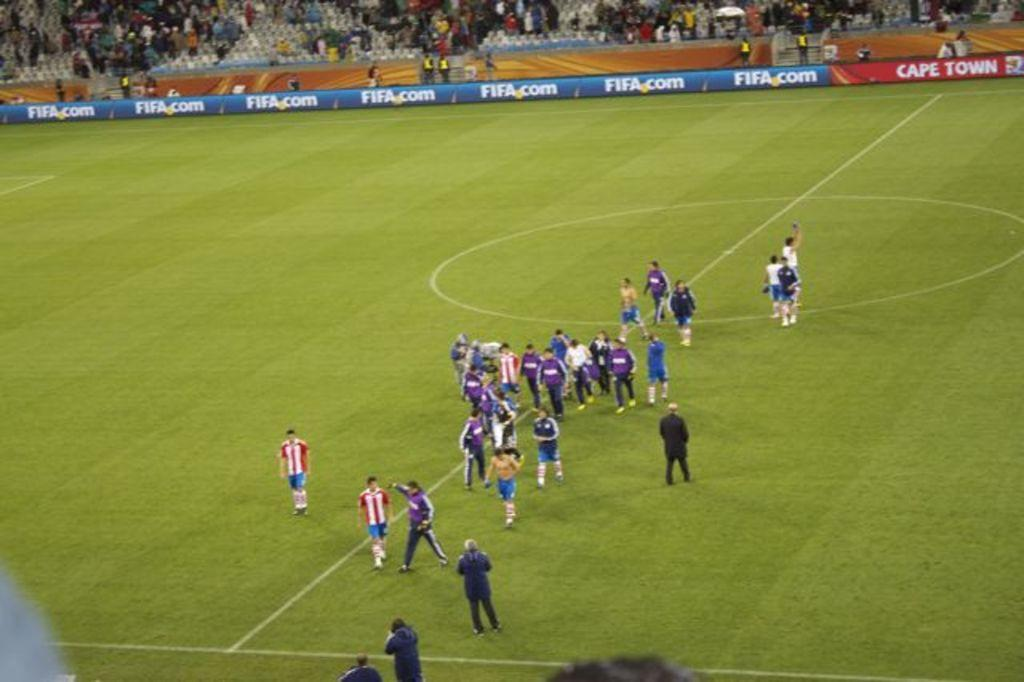What is the main subject of the image? The main subject of the image is a group of people. Where are the people located in the image? There are groups of people on the ground and at the top of the image. What can be seen at the top of the image besides the people? There are boards visible at the top of the image. What hobbies do the kittens enjoy in the image? There are no kittens present in the image, so their hobbies cannot be determined. Can you see any steam coming from the boards in the image? There is no steam visible in the image; only people, boards, and the ground are present. 